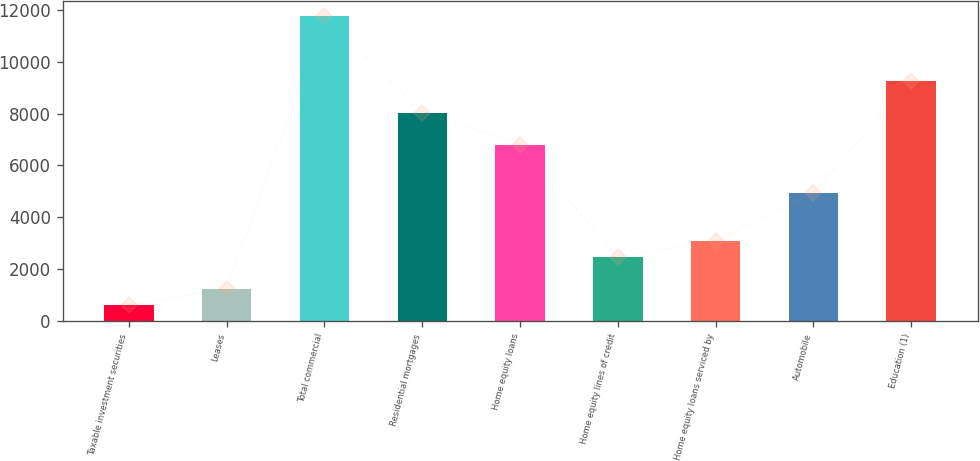Convert chart. <chart><loc_0><loc_0><loc_500><loc_500><bar_chart><fcel>Taxable investment securities<fcel>Leases<fcel>Total commercial<fcel>Residential mortgages<fcel>Home equity loans<fcel>Home equity lines of credit<fcel>Home equity loans serviced by<fcel>Automobile<fcel>Education (1)<nl><fcel>619.2<fcel>1237.4<fcel>11746.8<fcel>8037.6<fcel>6801.2<fcel>2473.8<fcel>3092<fcel>4946.6<fcel>9274<nl></chart> 